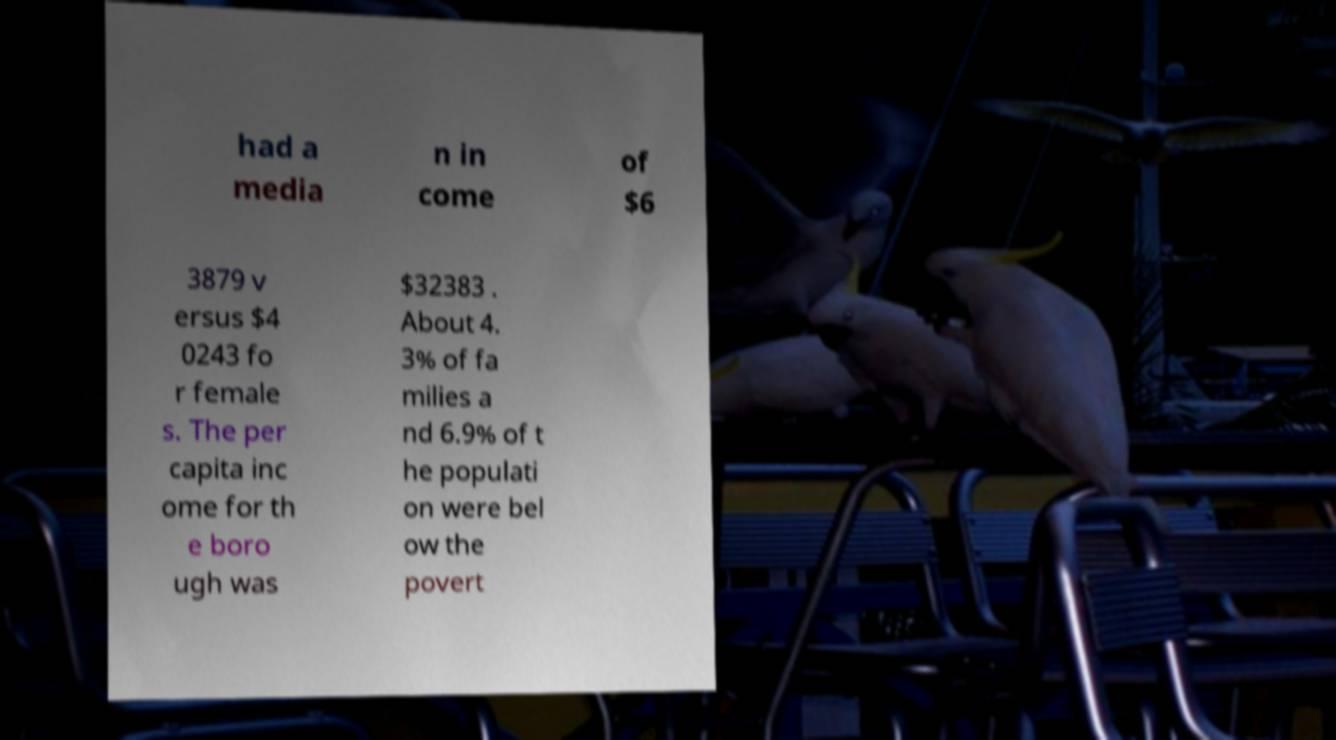There's text embedded in this image that I need extracted. Can you transcribe it verbatim? had a media n in come of $6 3879 v ersus $4 0243 fo r female s. The per capita inc ome for th e boro ugh was $32383 . About 4. 3% of fa milies a nd 6.9% of t he populati on were bel ow the povert 